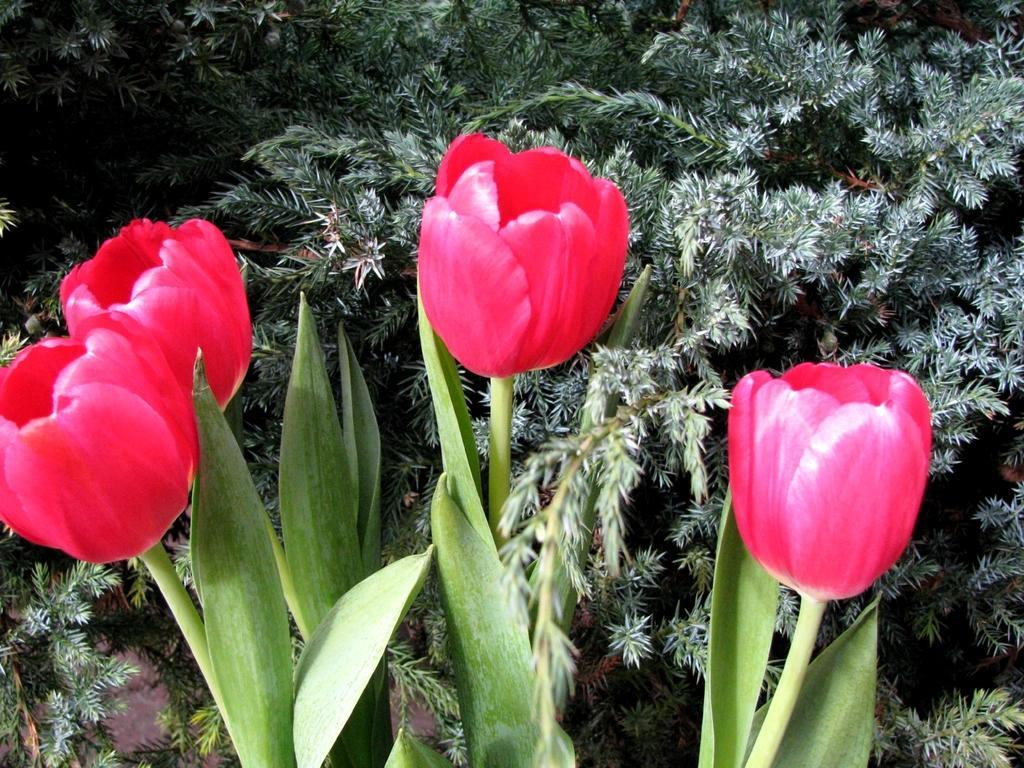How would you summarize this image in a sentence or two? In the foreground of the picture there are flowers and leaves. At the top we can see plants. 